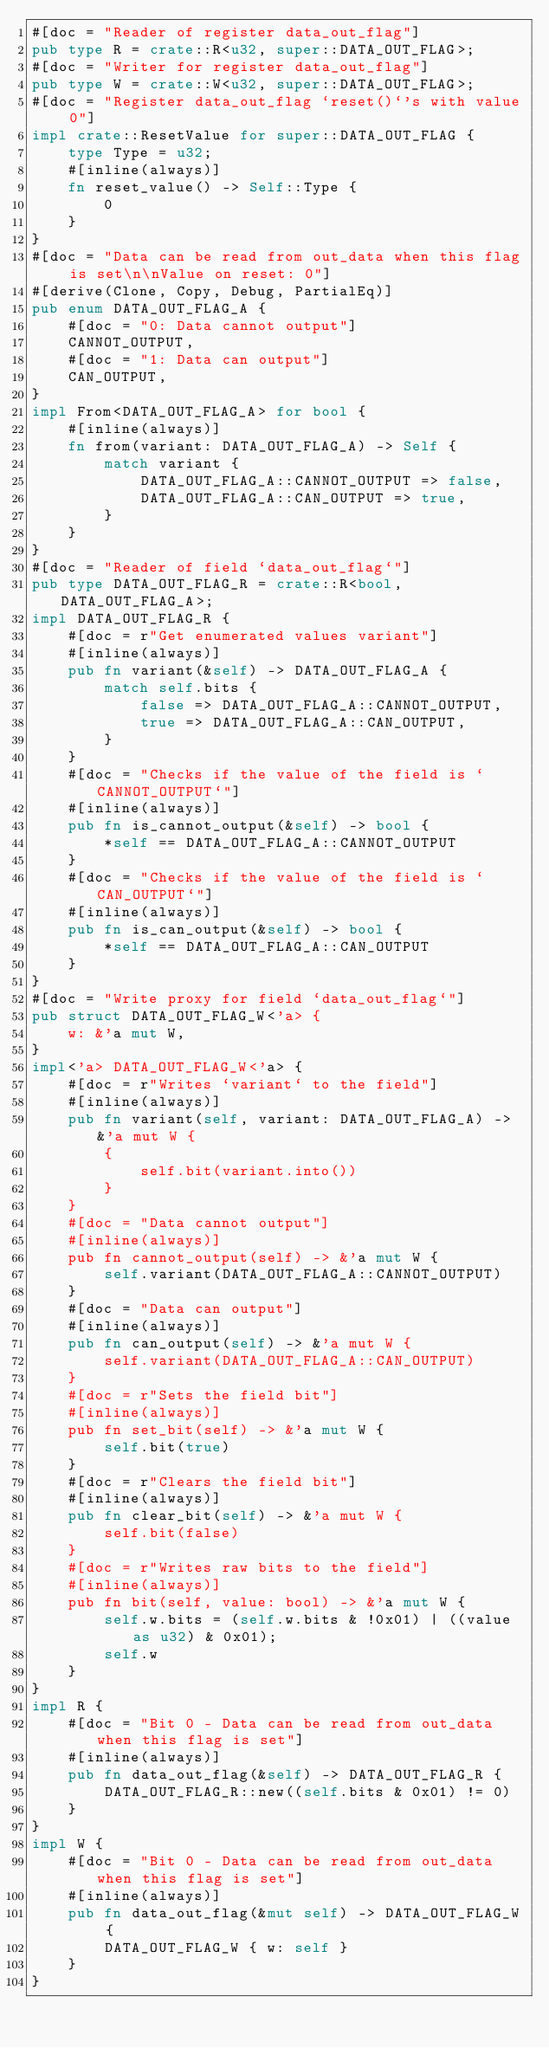Convert code to text. <code><loc_0><loc_0><loc_500><loc_500><_Rust_>#[doc = "Reader of register data_out_flag"]
pub type R = crate::R<u32, super::DATA_OUT_FLAG>;
#[doc = "Writer for register data_out_flag"]
pub type W = crate::W<u32, super::DATA_OUT_FLAG>;
#[doc = "Register data_out_flag `reset()`'s with value 0"]
impl crate::ResetValue for super::DATA_OUT_FLAG {
    type Type = u32;
    #[inline(always)]
    fn reset_value() -> Self::Type {
        0
    }
}
#[doc = "Data can be read from out_data when this flag is set\n\nValue on reset: 0"]
#[derive(Clone, Copy, Debug, PartialEq)]
pub enum DATA_OUT_FLAG_A {
    #[doc = "0: Data cannot output"]
    CANNOT_OUTPUT,
    #[doc = "1: Data can output"]
    CAN_OUTPUT,
}
impl From<DATA_OUT_FLAG_A> for bool {
    #[inline(always)]
    fn from(variant: DATA_OUT_FLAG_A) -> Self {
        match variant {
            DATA_OUT_FLAG_A::CANNOT_OUTPUT => false,
            DATA_OUT_FLAG_A::CAN_OUTPUT => true,
        }
    }
}
#[doc = "Reader of field `data_out_flag`"]
pub type DATA_OUT_FLAG_R = crate::R<bool, DATA_OUT_FLAG_A>;
impl DATA_OUT_FLAG_R {
    #[doc = r"Get enumerated values variant"]
    #[inline(always)]
    pub fn variant(&self) -> DATA_OUT_FLAG_A {
        match self.bits {
            false => DATA_OUT_FLAG_A::CANNOT_OUTPUT,
            true => DATA_OUT_FLAG_A::CAN_OUTPUT,
        }
    }
    #[doc = "Checks if the value of the field is `CANNOT_OUTPUT`"]
    #[inline(always)]
    pub fn is_cannot_output(&self) -> bool {
        *self == DATA_OUT_FLAG_A::CANNOT_OUTPUT
    }
    #[doc = "Checks if the value of the field is `CAN_OUTPUT`"]
    #[inline(always)]
    pub fn is_can_output(&self) -> bool {
        *self == DATA_OUT_FLAG_A::CAN_OUTPUT
    }
}
#[doc = "Write proxy for field `data_out_flag`"]
pub struct DATA_OUT_FLAG_W<'a> {
    w: &'a mut W,
}
impl<'a> DATA_OUT_FLAG_W<'a> {
    #[doc = r"Writes `variant` to the field"]
    #[inline(always)]
    pub fn variant(self, variant: DATA_OUT_FLAG_A) -> &'a mut W {
        {
            self.bit(variant.into())
        }
    }
    #[doc = "Data cannot output"]
    #[inline(always)]
    pub fn cannot_output(self) -> &'a mut W {
        self.variant(DATA_OUT_FLAG_A::CANNOT_OUTPUT)
    }
    #[doc = "Data can output"]
    #[inline(always)]
    pub fn can_output(self) -> &'a mut W {
        self.variant(DATA_OUT_FLAG_A::CAN_OUTPUT)
    }
    #[doc = r"Sets the field bit"]
    #[inline(always)]
    pub fn set_bit(self) -> &'a mut W {
        self.bit(true)
    }
    #[doc = r"Clears the field bit"]
    #[inline(always)]
    pub fn clear_bit(self) -> &'a mut W {
        self.bit(false)
    }
    #[doc = r"Writes raw bits to the field"]
    #[inline(always)]
    pub fn bit(self, value: bool) -> &'a mut W {
        self.w.bits = (self.w.bits & !0x01) | ((value as u32) & 0x01);
        self.w
    }
}
impl R {
    #[doc = "Bit 0 - Data can be read from out_data when this flag is set"]
    #[inline(always)]
    pub fn data_out_flag(&self) -> DATA_OUT_FLAG_R {
        DATA_OUT_FLAG_R::new((self.bits & 0x01) != 0)
    }
}
impl W {
    #[doc = "Bit 0 - Data can be read from out_data when this flag is set"]
    #[inline(always)]
    pub fn data_out_flag(&mut self) -> DATA_OUT_FLAG_W {
        DATA_OUT_FLAG_W { w: self }
    }
}
</code> 